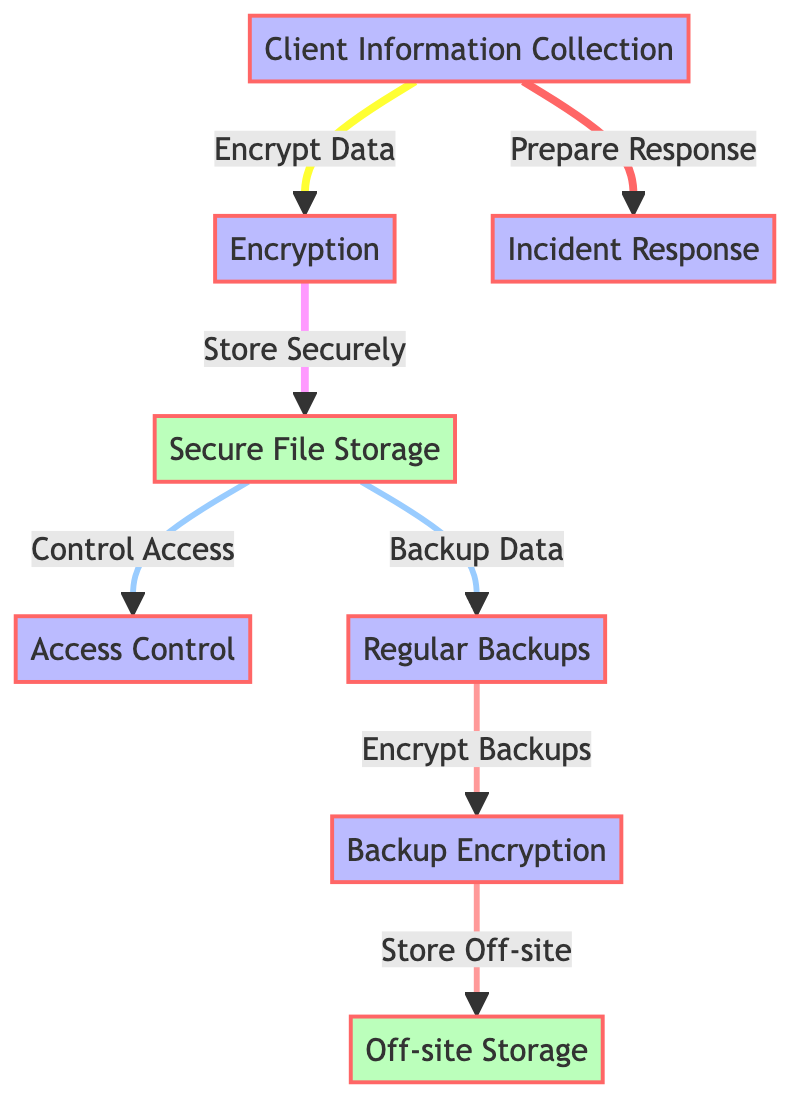What is the first step in the file security process? The first step in the process is 'Client Information Collection', as indicated in the diagram.
Answer: Client Information Collection How many processes are depicted in the diagram? There are six processes shown in the diagram: Client Information Collection, Encryption, Access Control, Regular Backups, Backup Encryption, and Incident Response.
Answer: Six What follows Secure File Storage? The diagram shows that after Secure File Storage, there are two subsequent actions: Control Access and Backup Data.
Answer: Control Access and Backup Data What is done with data after Regular Backups? Following Regular Backups, Backup Encryption is performed according to the flow illustrated in the diagram.
Answer: Backup Encryption How many storage components are there? The diagram includes two storage components: Secure File Storage and Off-site Storage.
Answer: Two What is the relationship between Backup Data and Backup Encryption? Backup Data leads to Backup Encryption, as indicated by the directional flow from Regular Backups to Backup Encryption in the diagram.
Answer: Backup Data leads to Backup Encryption What does Incident Response connect to? The Incident Response connects to Client Information Collection with a direct line shown in the diagram, indicating the preparation phase for addressing potential incidents.
Answer: Client Information Collection Which step addresses the need for data access control? Access Control is the step that specifically addresses the need to control access to the securely stored files.
Answer: Access Control Where do encrypted backups get stored? Encrypted backups are stored Off-site as indicated in the diagram's flow from Backup Encryption to Off-site Storage.
Answer: Off-site Storage 